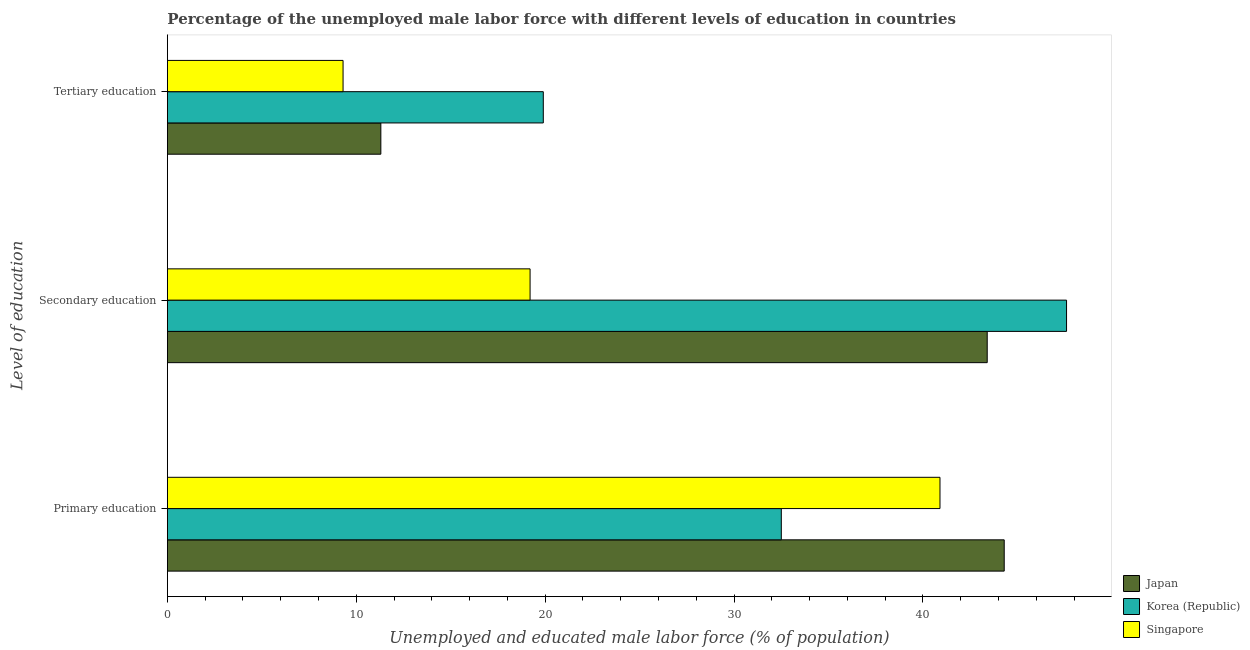How many different coloured bars are there?
Your answer should be compact. 3. How many groups of bars are there?
Provide a short and direct response. 3. Are the number of bars per tick equal to the number of legend labels?
Provide a short and direct response. Yes. Are the number of bars on each tick of the Y-axis equal?
Make the answer very short. Yes. How many bars are there on the 1st tick from the bottom?
Provide a short and direct response. 3. What is the label of the 3rd group of bars from the top?
Provide a short and direct response. Primary education. What is the percentage of male labor force who received tertiary education in Korea (Republic)?
Keep it short and to the point. 19.9. Across all countries, what is the maximum percentage of male labor force who received secondary education?
Ensure brevity in your answer.  47.6. Across all countries, what is the minimum percentage of male labor force who received tertiary education?
Provide a succinct answer. 9.3. In which country was the percentage of male labor force who received primary education minimum?
Offer a very short reply. Korea (Republic). What is the total percentage of male labor force who received tertiary education in the graph?
Make the answer very short. 40.5. What is the difference between the percentage of male labor force who received tertiary education in Korea (Republic) and that in Japan?
Your answer should be very brief. 8.6. What is the difference between the percentage of male labor force who received secondary education in Korea (Republic) and the percentage of male labor force who received primary education in Singapore?
Your answer should be compact. 6.7. What is the average percentage of male labor force who received secondary education per country?
Make the answer very short. 36.73. What is the difference between the percentage of male labor force who received tertiary education and percentage of male labor force who received secondary education in Korea (Republic)?
Offer a very short reply. -27.7. What is the ratio of the percentage of male labor force who received tertiary education in Japan to that in Korea (Republic)?
Ensure brevity in your answer.  0.57. Is the percentage of male labor force who received secondary education in Singapore less than that in Japan?
Provide a succinct answer. Yes. What is the difference between the highest and the second highest percentage of male labor force who received secondary education?
Keep it short and to the point. 4.2. What is the difference between the highest and the lowest percentage of male labor force who received tertiary education?
Your answer should be compact. 10.6. In how many countries, is the percentage of male labor force who received primary education greater than the average percentage of male labor force who received primary education taken over all countries?
Make the answer very short. 2. Is the sum of the percentage of male labor force who received secondary education in Japan and Singapore greater than the maximum percentage of male labor force who received tertiary education across all countries?
Offer a terse response. Yes. What does the 1st bar from the top in Primary education represents?
Ensure brevity in your answer.  Singapore. How many countries are there in the graph?
Your response must be concise. 3. What is the difference between two consecutive major ticks on the X-axis?
Your answer should be compact. 10. Are the values on the major ticks of X-axis written in scientific E-notation?
Provide a succinct answer. No. Does the graph contain any zero values?
Ensure brevity in your answer.  No. Does the graph contain grids?
Your answer should be compact. No. What is the title of the graph?
Ensure brevity in your answer.  Percentage of the unemployed male labor force with different levels of education in countries. What is the label or title of the X-axis?
Offer a very short reply. Unemployed and educated male labor force (% of population). What is the label or title of the Y-axis?
Make the answer very short. Level of education. What is the Unemployed and educated male labor force (% of population) in Japan in Primary education?
Give a very brief answer. 44.3. What is the Unemployed and educated male labor force (% of population) in Korea (Republic) in Primary education?
Provide a succinct answer. 32.5. What is the Unemployed and educated male labor force (% of population) of Singapore in Primary education?
Give a very brief answer. 40.9. What is the Unemployed and educated male labor force (% of population) of Japan in Secondary education?
Ensure brevity in your answer.  43.4. What is the Unemployed and educated male labor force (% of population) of Korea (Republic) in Secondary education?
Provide a short and direct response. 47.6. What is the Unemployed and educated male labor force (% of population) in Singapore in Secondary education?
Your answer should be very brief. 19.2. What is the Unemployed and educated male labor force (% of population) in Japan in Tertiary education?
Make the answer very short. 11.3. What is the Unemployed and educated male labor force (% of population) in Korea (Republic) in Tertiary education?
Your answer should be compact. 19.9. What is the Unemployed and educated male labor force (% of population) in Singapore in Tertiary education?
Provide a succinct answer. 9.3. Across all Level of education, what is the maximum Unemployed and educated male labor force (% of population) in Japan?
Your response must be concise. 44.3. Across all Level of education, what is the maximum Unemployed and educated male labor force (% of population) in Korea (Republic)?
Keep it short and to the point. 47.6. Across all Level of education, what is the maximum Unemployed and educated male labor force (% of population) of Singapore?
Offer a terse response. 40.9. Across all Level of education, what is the minimum Unemployed and educated male labor force (% of population) of Japan?
Make the answer very short. 11.3. Across all Level of education, what is the minimum Unemployed and educated male labor force (% of population) of Korea (Republic)?
Offer a very short reply. 19.9. Across all Level of education, what is the minimum Unemployed and educated male labor force (% of population) of Singapore?
Give a very brief answer. 9.3. What is the total Unemployed and educated male labor force (% of population) of Korea (Republic) in the graph?
Provide a short and direct response. 100. What is the total Unemployed and educated male labor force (% of population) of Singapore in the graph?
Make the answer very short. 69.4. What is the difference between the Unemployed and educated male labor force (% of population) of Japan in Primary education and that in Secondary education?
Provide a succinct answer. 0.9. What is the difference between the Unemployed and educated male labor force (% of population) of Korea (Republic) in Primary education and that in Secondary education?
Provide a succinct answer. -15.1. What is the difference between the Unemployed and educated male labor force (% of population) of Singapore in Primary education and that in Secondary education?
Make the answer very short. 21.7. What is the difference between the Unemployed and educated male labor force (% of population) in Japan in Primary education and that in Tertiary education?
Provide a succinct answer. 33. What is the difference between the Unemployed and educated male labor force (% of population) of Korea (Republic) in Primary education and that in Tertiary education?
Offer a very short reply. 12.6. What is the difference between the Unemployed and educated male labor force (% of population) of Singapore in Primary education and that in Tertiary education?
Your response must be concise. 31.6. What is the difference between the Unemployed and educated male labor force (% of population) of Japan in Secondary education and that in Tertiary education?
Provide a succinct answer. 32.1. What is the difference between the Unemployed and educated male labor force (% of population) in Korea (Republic) in Secondary education and that in Tertiary education?
Your response must be concise. 27.7. What is the difference between the Unemployed and educated male labor force (% of population) of Singapore in Secondary education and that in Tertiary education?
Your answer should be compact. 9.9. What is the difference between the Unemployed and educated male labor force (% of population) of Japan in Primary education and the Unemployed and educated male labor force (% of population) of Singapore in Secondary education?
Provide a succinct answer. 25.1. What is the difference between the Unemployed and educated male labor force (% of population) in Japan in Primary education and the Unemployed and educated male labor force (% of population) in Korea (Republic) in Tertiary education?
Ensure brevity in your answer.  24.4. What is the difference between the Unemployed and educated male labor force (% of population) in Korea (Republic) in Primary education and the Unemployed and educated male labor force (% of population) in Singapore in Tertiary education?
Provide a short and direct response. 23.2. What is the difference between the Unemployed and educated male labor force (% of population) of Japan in Secondary education and the Unemployed and educated male labor force (% of population) of Singapore in Tertiary education?
Offer a terse response. 34.1. What is the difference between the Unemployed and educated male labor force (% of population) in Korea (Republic) in Secondary education and the Unemployed and educated male labor force (% of population) in Singapore in Tertiary education?
Offer a terse response. 38.3. What is the average Unemployed and educated male labor force (% of population) in Korea (Republic) per Level of education?
Ensure brevity in your answer.  33.33. What is the average Unemployed and educated male labor force (% of population) in Singapore per Level of education?
Your response must be concise. 23.13. What is the difference between the Unemployed and educated male labor force (% of population) in Japan and Unemployed and educated male labor force (% of population) in Korea (Republic) in Primary education?
Provide a short and direct response. 11.8. What is the difference between the Unemployed and educated male labor force (% of population) of Japan and Unemployed and educated male labor force (% of population) of Singapore in Secondary education?
Keep it short and to the point. 24.2. What is the difference between the Unemployed and educated male labor force (% of population) in Korea (Republic) and Unemployed and educated male labor force (% of population) in Singapore in Secondary education?
Your response must be concise. 28.4. What is the difference between the Unemployed and educated male labor force (% of population) in Japan and Unemployed and educated male labor force (% of population) in Korea (Republic) in Tertiary education?
Provide a short and direct response. -8.6. What is the difference between the Unemployed and educated male labor force (% of population) in Korea (Republic) and Unemployed and educated male labor force (% of population) in Singapore in Tertiary education?
Offer a terse response. 10.6. What is the ratio of the Unemployed and educated male labor force (% of population) of Japan in Primary education to that in Secondary education?
Provide a succinct answer. 1.02. What is the ratio of the Unemployed and educated male labor force (% of population) in Korea (Republic) in Primary education to that in Secondary education?
Provide a succinct answer. 0.68. What is the ratio of the Unemployed and educated male labor force (% of population) in Singapore in Primary education to that in Secondary education?
Offer a very short reply. 2.13. What is the ratio of the Unemployed and educated male labor force (% of population) of Japan in Primary education to that in Tertiary education?
Your answer should be very brief. 3.92. What is the ratio of the Unemployed and educated male labor force (% of population) in Korea (Republic) in Primary education to that in Tertiary education?
Give a very brief answer. 1.63. What is the ratio of the Unemployed and educated male labor force (% of population) in Singapore in Primary education to that in Tertiary education?
Provide a succinct answer. 4.4. What is the ratio of the Unemployed and educated male labor force (% of population) of Japan in Secondary education to that in Tertiary education?
Your answer should be compact. 3.84. What is the ratio of the Unemployed and educated male labor force (% of population) in Korea (Republic) in Secondary education to that in Tertiary education?
Your response must be concise. 2.39. What is the ratio of the Unemployed and educated male labor force (% of population) of Singapore in Secondary education to that in Tertiary education?
Provide a succinct answer. 2.06. What is the difference between the highest and the second highest Unemployed and educated male labor force (% of population) in Singapore?
Offer a very short reply. 21.7. What is the difference between the highest and the lowest Unemployed and educated male labor force (% of population) in Japan?
Provide a short and direct response. 33. What is the difference between the highest and the lowest Unemployed and educated male labor force (% of population) of Korea (Republic)?
Offer a terse response. 27.7. What is the difference between the highest and the lowest Unemployed and educated male labor force (% of population) in Singapore?
Your answer should be compact. 31.6. 